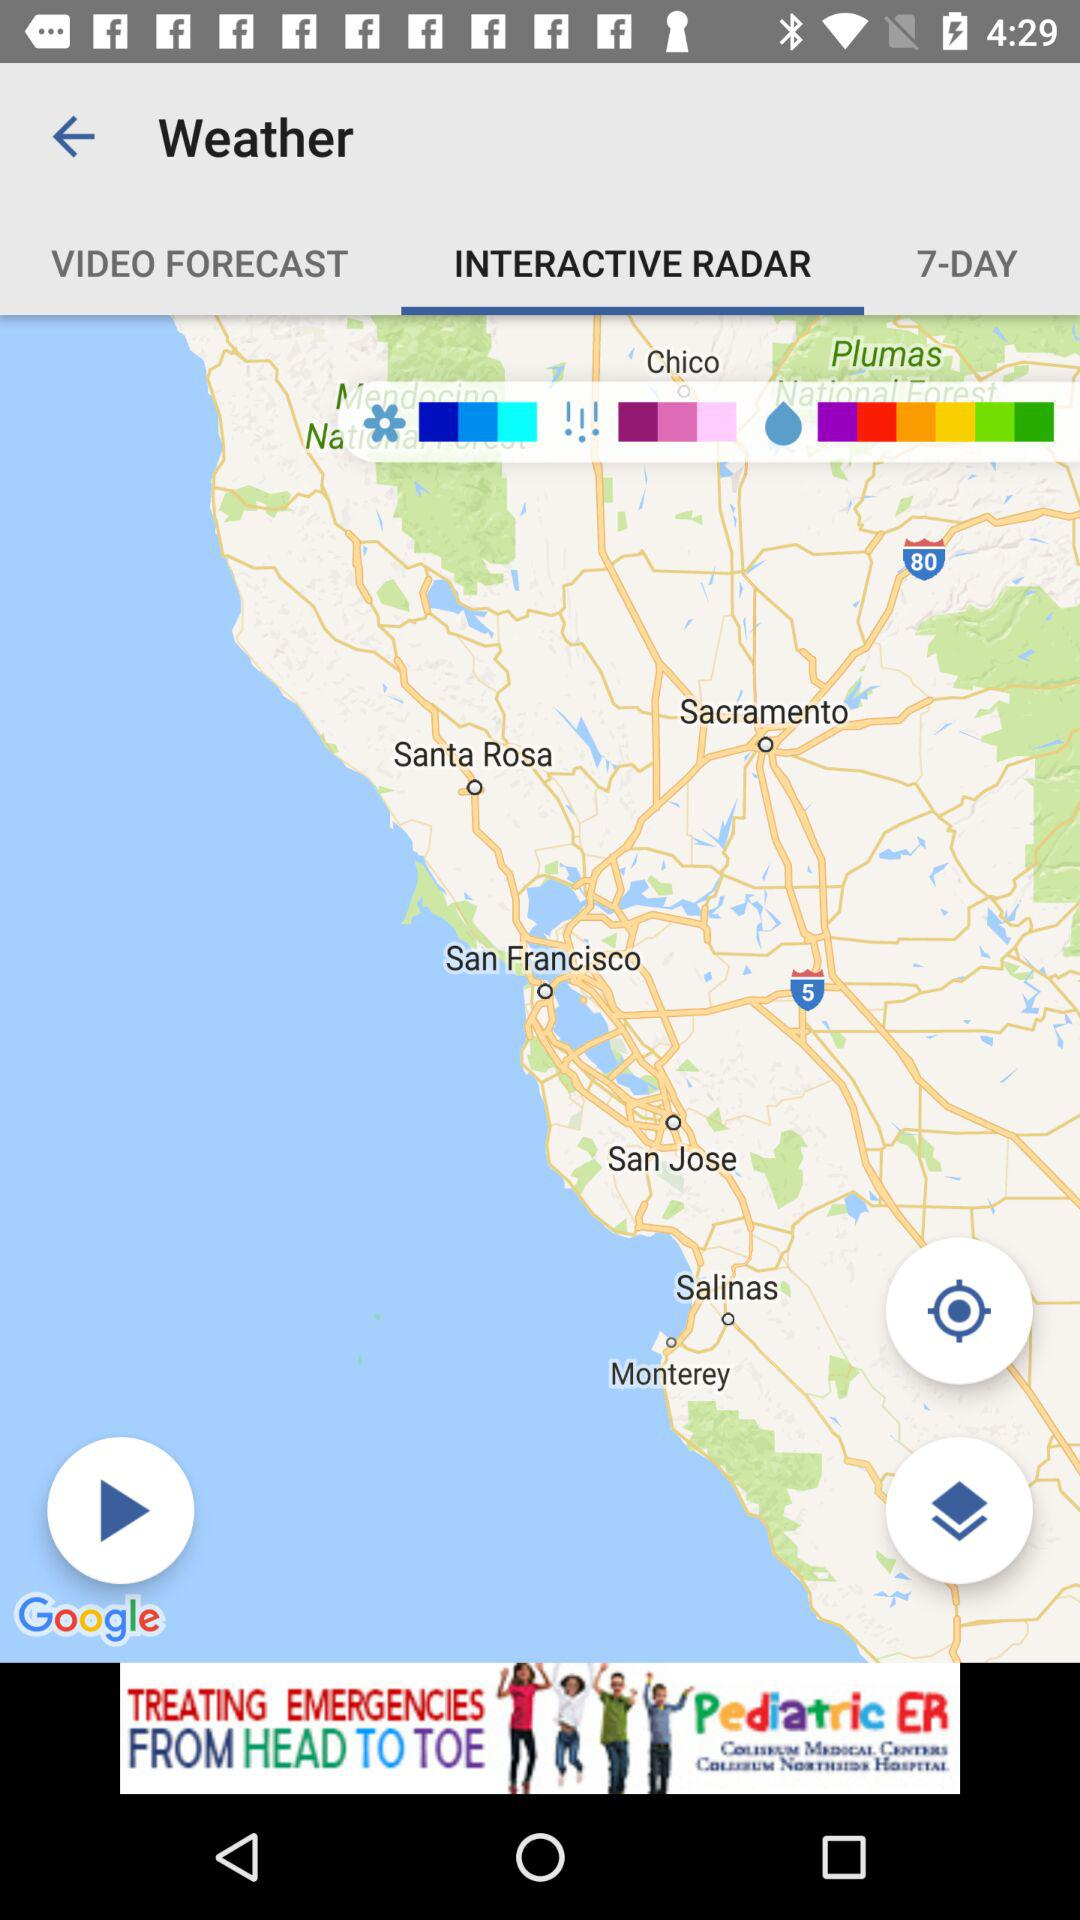What is the mentioned number of days? The mentioned number of days is 7. 